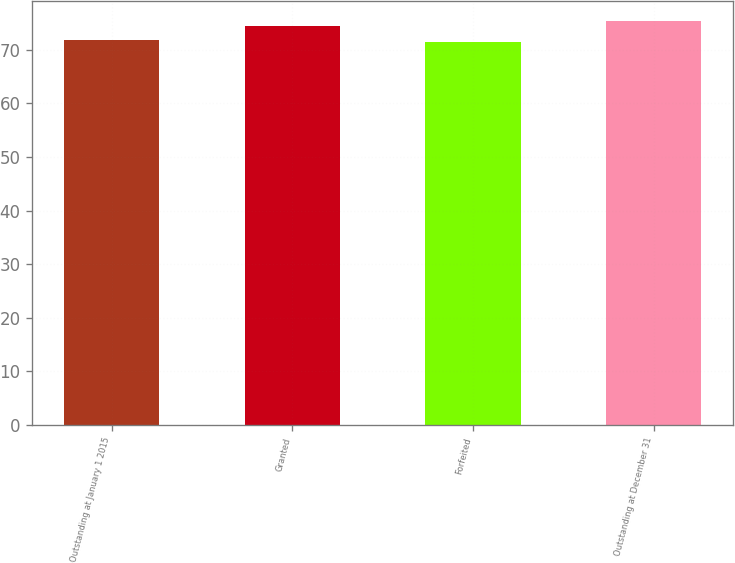Convert chart. <chart><loc_0><loc_0><loc_500><loc_500><bar_chart><fcel>Outstanding at January 1 2015<fcel>Granted<fcel>Forfeited<fcel>Outstanding at December 31<nl><fcel>71.78<fcel>74.38<fcel>71.39<fcel>75.32<nl></chart> 